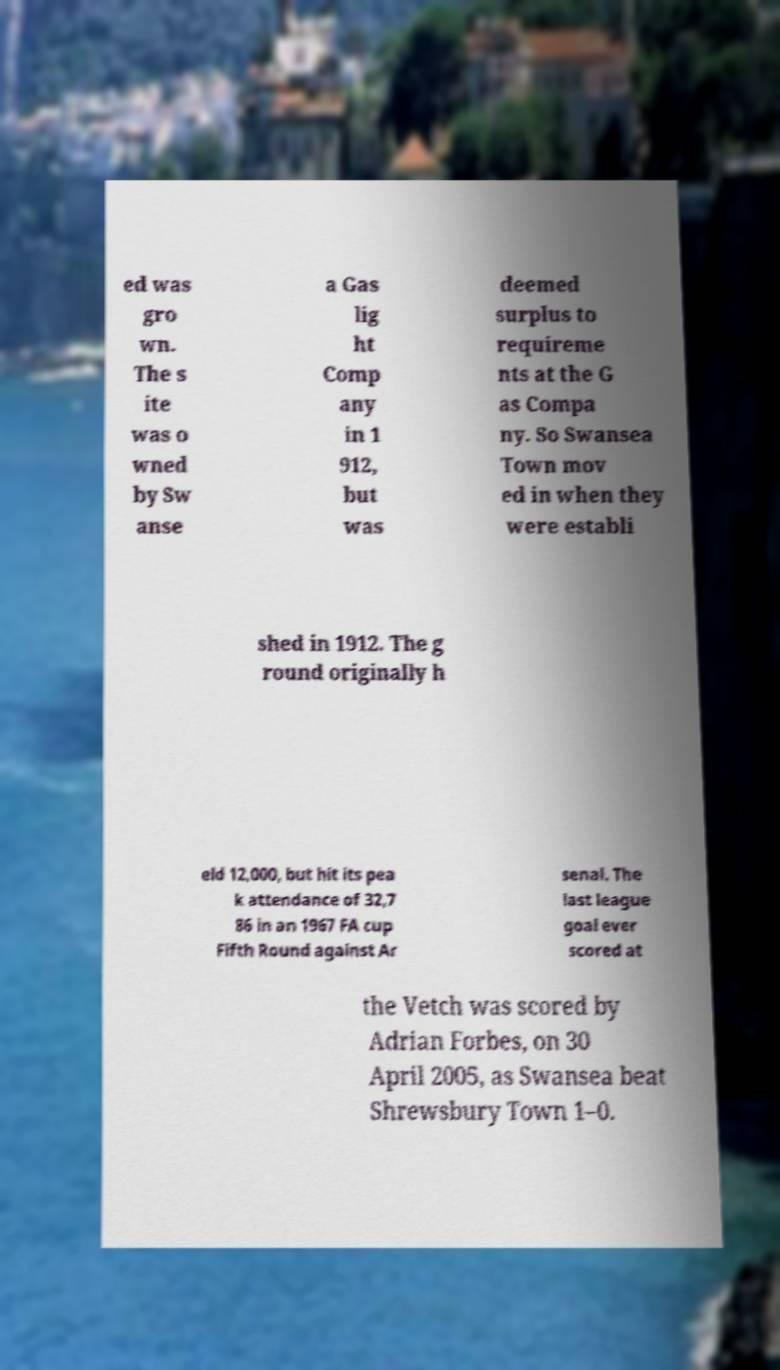Please read and relay the text visible in this image. What does it say? ed was gro wn. The s ite was o wned by Sw anse a Gas lig ht Comp any in 1 912, but was deemed surplus to requireme nts at the G as Compa ny. So Swansea Town mov ed in when they were establi shed in 1912. The g round originally h eld 12,000, but hit its pea k attendance of 32,7 86 in an 1967 FA cup Fifth Round against Ar senal. The last league goal ever scored at the Vetch was scored by Adrian Forbes, on 30 April 2005, as Swansea beat Shrewsbury Town 1–0. 